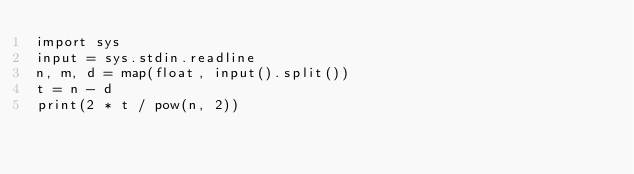<code> <loc_0><loc_0><loc_500><loc_500><_Python_>import sys
input = sys.stdin.readline
n, m, d = map(float, input().split())
t = n - d
print(2 * t / pow(n, 2))</code> 